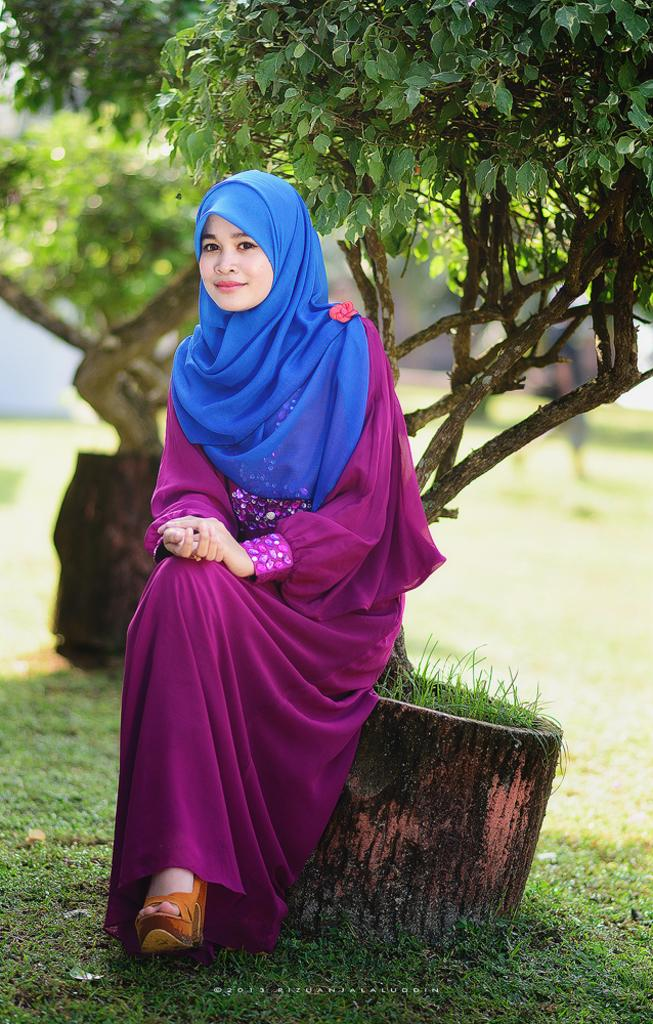Who is the main subject in the image? There is a woman in the image. What is the woman doing in the image? The woman is sitting on a pot. What can be seen in the background of the image? There are trees visible in the background of the image. What type of music can be heard playing in the image? There is no music present in the image, so it cannot be heard. 